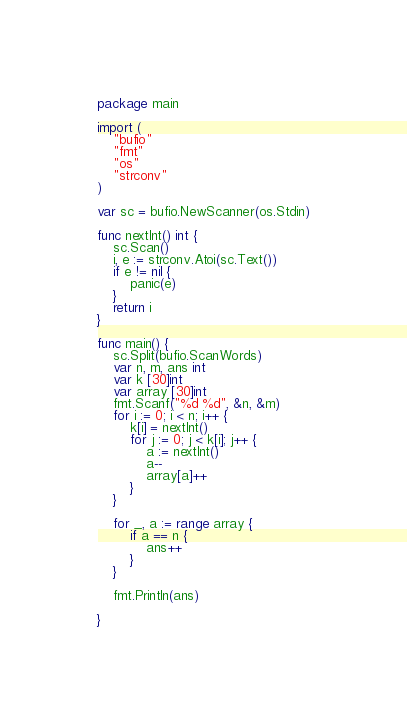<code> <loc_0><loc_0><loc_500><loc_500><_Go_>package main

import (
	"bufio"
	"fmt"
	"os"
	"strconv"
)

var sc = bufio.NewScanner(os.Stdin)

func nextInt() int {
	sc.Scan()
	i, e := strconv.Atoi(sc.Text())
	if e != nil {
		panic(e)
	}
	return i
}

func main() {
	sc.Split(bufio.ScanWords)
	var n, m, ans int
	var k [30]int
	var array [30]int
	fmt.Scanf("%d %d", &n, &m)
	for i := 0; i < n; i++ {
		k[i] = nextInt()
		for j := 0; j < k[i]; j++ {
			a := nextInt()
			a--
			array[a]++
		}
	}

	for _, a := range array {
		if a == n {
			ans++
		}
	}

	fmt.Println(ans)

}
</code> 